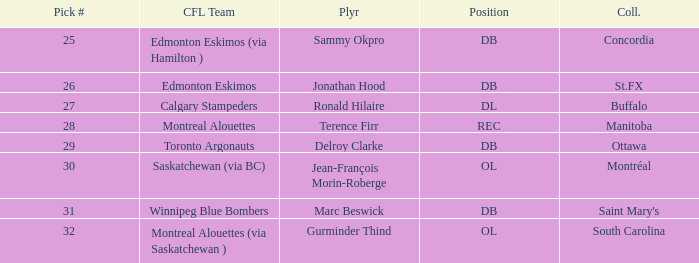Which CFL Team has a Pick # larger than 31? Montreal Alouettes (via Saskatchewan ). 